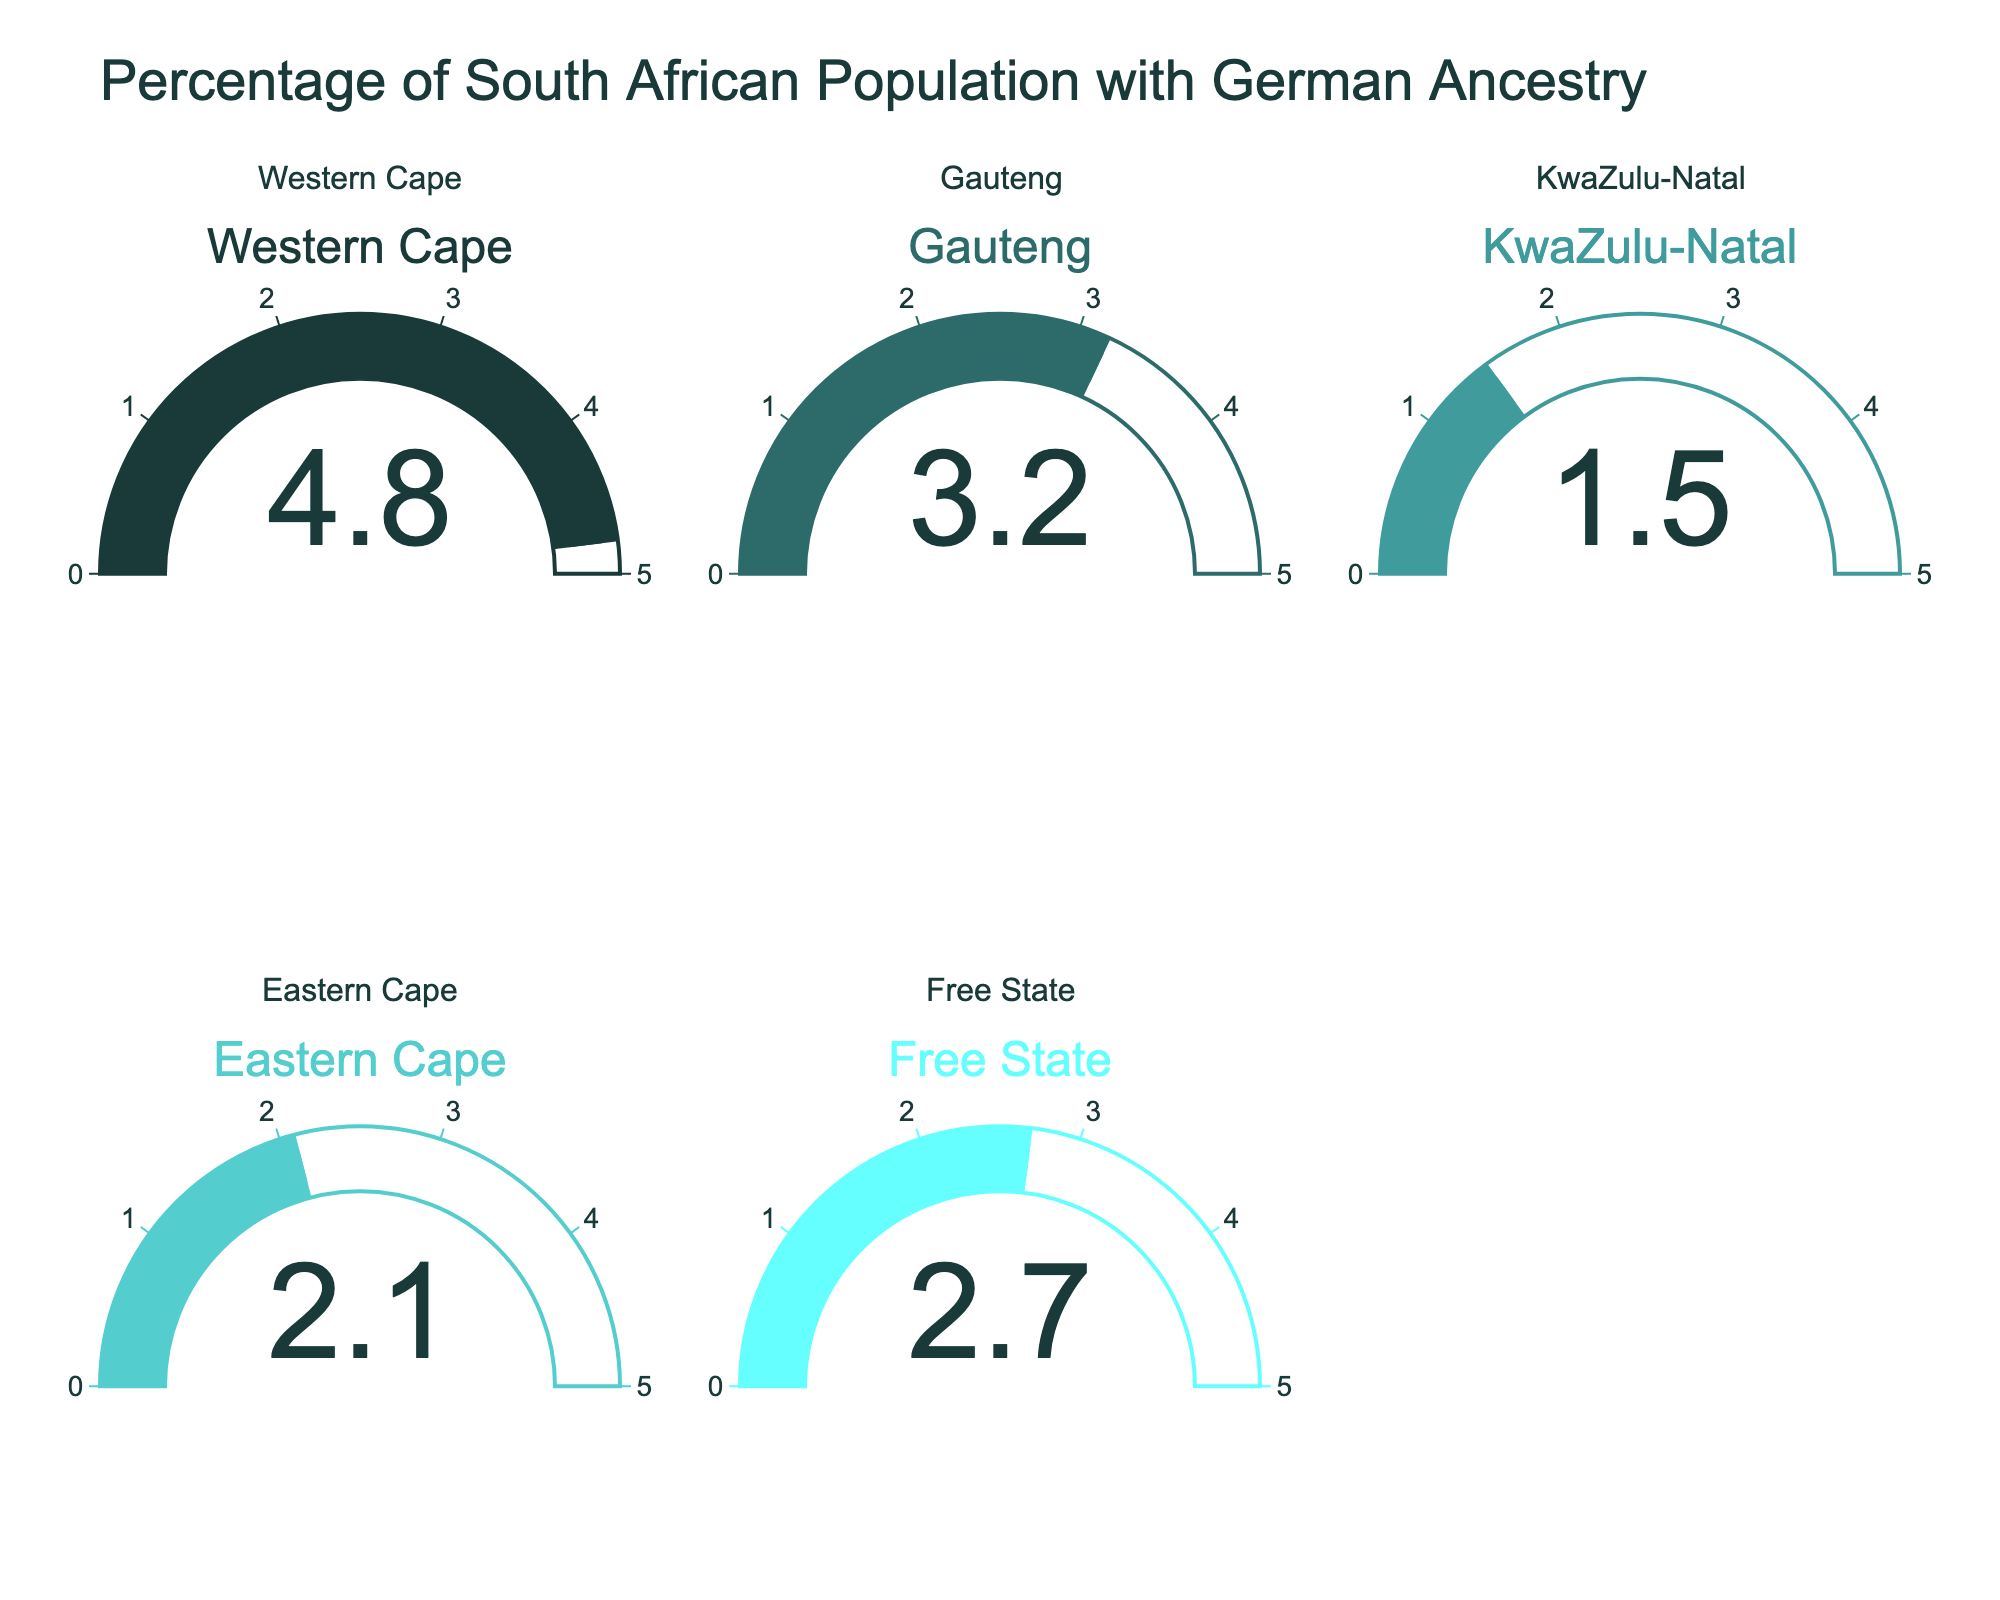what is the title of the chart? The title of the chart is prominently displayed at the top. It reads "Percentage of South African Population with German Ancestry".
Answer: Percentage of South African Population with German Ancestry which province has the highest percentage of people with German ancestry? By looking at each gauge, Western Cape has the highest value, which is 4.8%.
Answer: Western Cape What is the combined percentage of German ancestry in Gauteng and Eastern Cape? Gauteng has 3.2%, and Eastern Cape has 2.1%. Adding these percentages: 3.2% + 2.1% = 5.3%.
Answer: 5.3% Which province has the lowest percentage of German ancestry? Each gauge displays the percentage. KwaZulu-Natal has the lowest at 1.5%.
Answer: KwaZulu-Natal How much greater is the percentage of German ancestry in the Western Cape compared to KwaZulu-Natal? The Western Cape has 4.8%, and KwaZulu-Natal has 1.5%. Subtracting 1.5% from 4.8% gives 4.8% - 1.5% = 3.3%.
Answer: 3.3% What is the mean percentage of the population with German ancestry across all the provinces shown? The percentages are 4.8%, 3.2%, 1.5%, 2.1%, and 2.7%. Adding these values: 4.8% + 3.2% + 1.5% + 2.1% + 2.7% = 14.3%. To find the mean, divide by 5: 14.3% / 5 = 2.86%.
Answer: 2.86% Which two provinces have percentages closest to each other? Looking at the values, Free State has 2.7% and Eastern Cape has 2.1%. The difference is 2.7% - 2.1% = 0.6%, which is the smallest difference compared to other pairs.
Answer: Free State and Eastern Cape What color is used for the gauge representing Gauteng? The gauge for Gauteng uses a teal-ish green color which is consistent with the custom color scale defined for each region.
Answer: Teal-ish green 